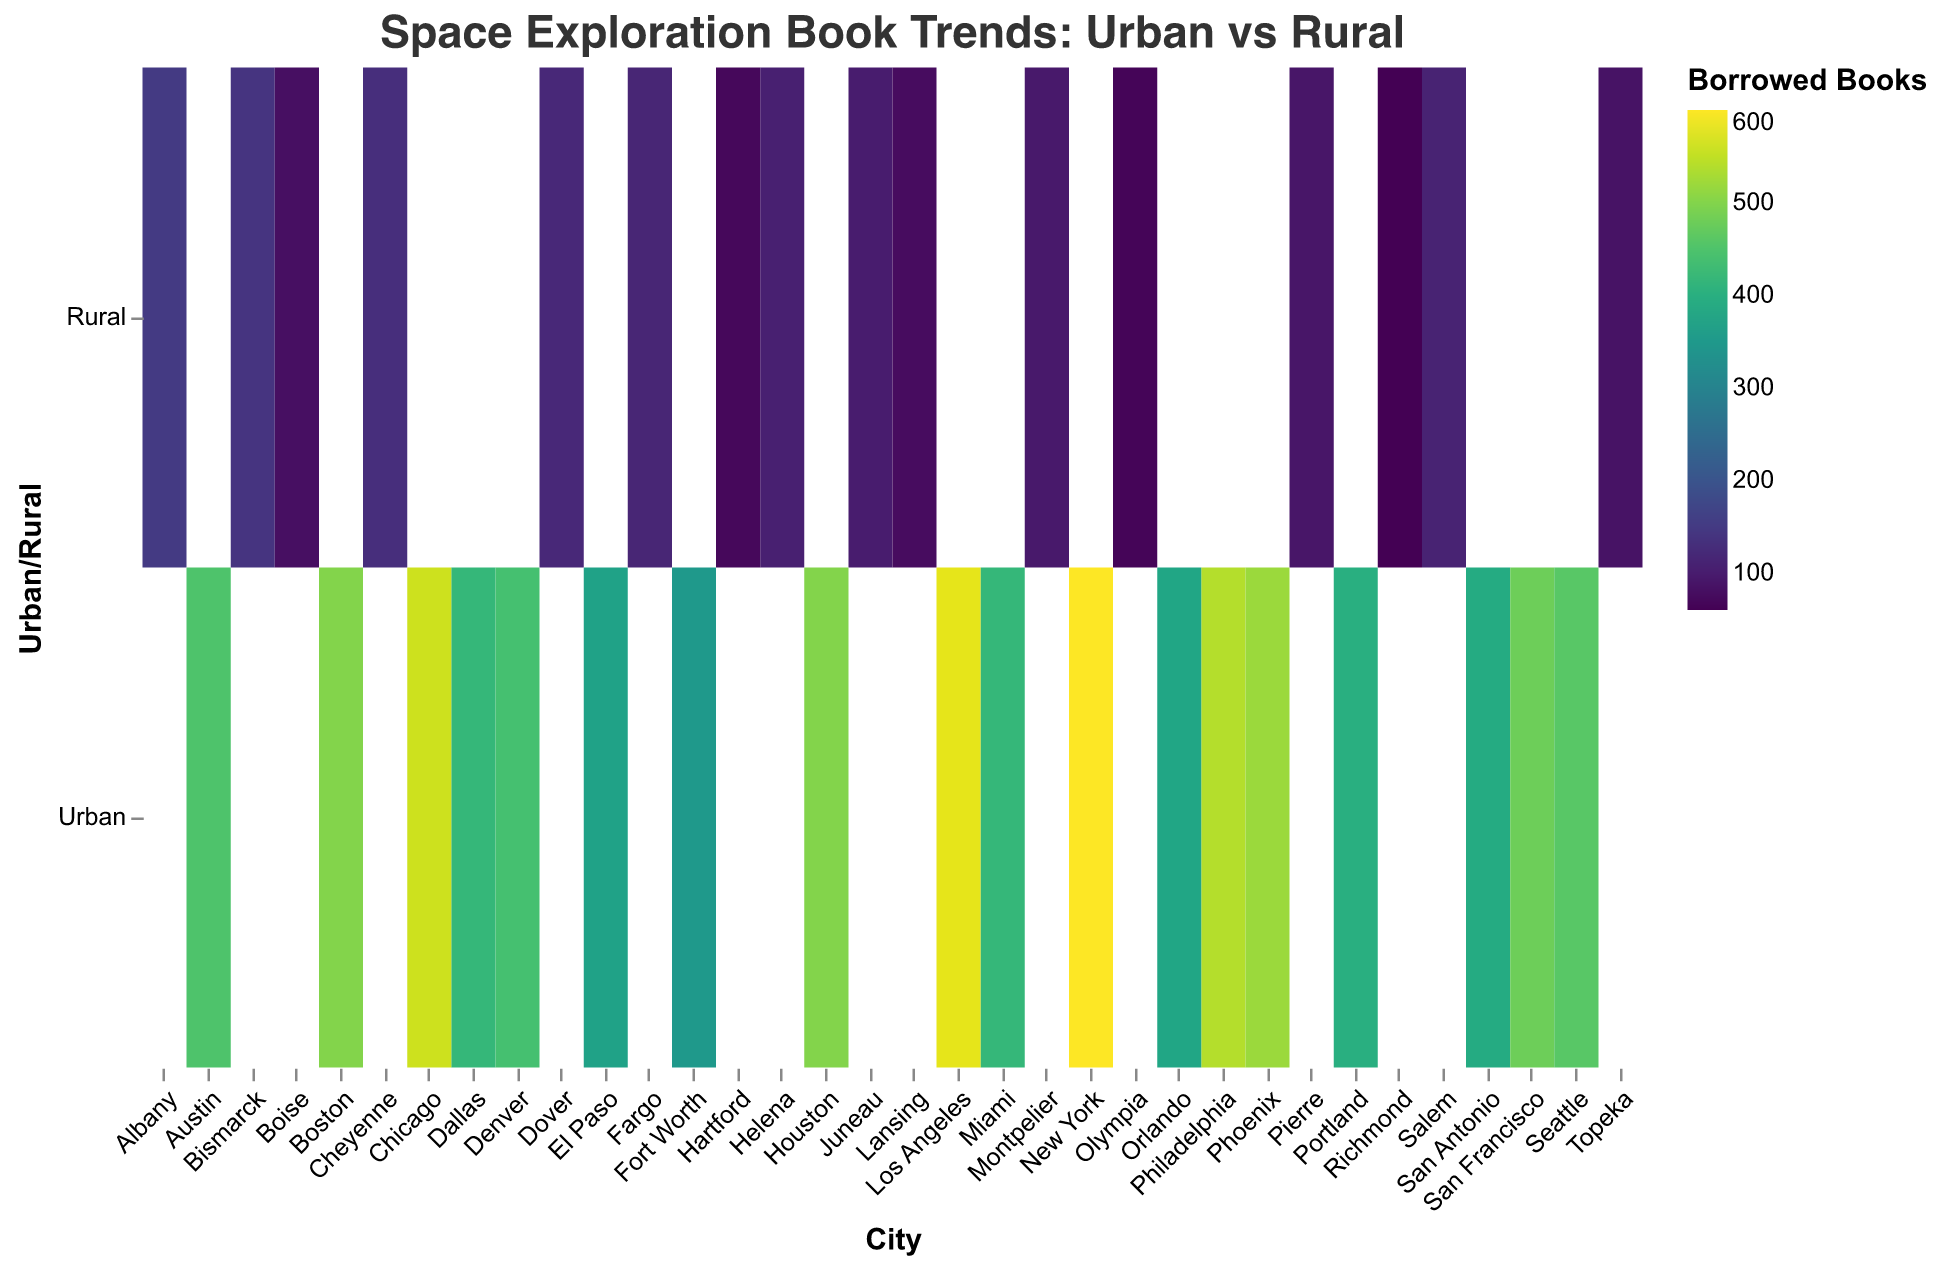What's the title of the figure? The title is usually located at the top of the figure. In this case, it reads "Space Exploration Book Trends: Urban vs Rural".
Answer: Space Exploration Book Trends: Urban vs Rural How many urban libraries have book borrowing counts over 500? Looking at the heatmap, we identify all urban libraries with a color indicating higher values for borrowed books and match them to those above 500. Cities like New York, Los Angeles, Chicago, Philadelphia, and Phoenix show high values.
Answer: 5 Which city has the highest number of borrowed books in the rural category? By examining the intensity of the colors and checking the tooltip data for rural areas, Albany has the highest number of borrowed books in the rural category with 150.
Answer: Albany What is the difference in borrowed books between New York Public Library and Seattle Public Library? New York Public Library (600) and Seattle Public Library (460). Subtracting these values: 600 - 460.
Answer: 140 Which rural city has the least number of purchased books? By observing the color intensity for purchased books in rural areas and confirming with tooltips, Richmond has the least number of purchased books at 20.
Answer: Richmond Compare the total number of borrowed books between Houston and Fort Worth in urban areas. Adding borrowed books of Houston (500) and Fort Worth (350) gives 500 + 350.
Answer: 850 Identify the city with the highest number of purchased books overall. By evaluating color intensities for purchased books across all cities and checking tooltips, New York has the highest number of purchased books at 500.
Answer: New York What is the average number of borrowed books across all rural libraries? Summing the borrowed books for all rural libraries and dividing by the number of rural libraries: (150 + 140 + 130 + 120 + 115 + 110 + 105 + 100 + 95 + 90 + 85 + 80 + 75 + 70 + 65 + 60) / 16 = 1500 / 16.
Answer: 93.75 Which rural city has the highest borrowing to purchasing ratio for space exploration books? We calculate the ratio for each rural city by dividing borrowed books by purchased books, then identify the highest ratio: Albany (150/100), Bismarck (140/90), Cheyenne (130/85), and so on. Albany (1.5) has the highest ratio.
Answer: Albany How does the borrowing trend in urban areas react compared to rural areas? Observing the overall color differences between urban and rural areas, urban areas show more intense colors, indicating higher borrowing trends compared to the rural areas which have less intense and lighter colors.
Answer: Urban areas have higher borrowing trends 